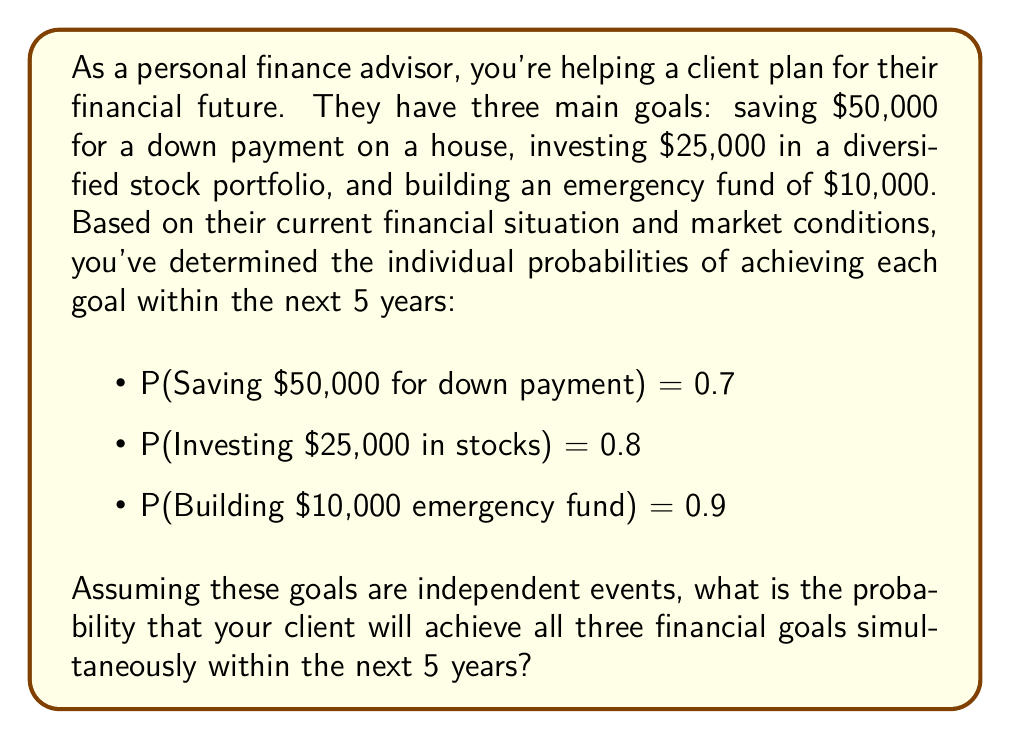Could you help me with this problem? To solve this problem, we need to use the multiplication rule for independent events. Since the question states that these goals are independent, we can multiply their individual probabilities to find the joint probability of all three events occurring simultaneously.

Let's define our events:
A = Saving $50,000 for down payment
B = Investing $25,000 in stocks
C = Building $10,000 emergency fund

We're given:
P(A) = 0.7
P(B) = 0.8
P(C) = 0.9

The joint probability of all three events occurring is:

$$P(A \cap B \cap C) = P(A) \times P(B) \times P(C)$$

Substituting the values:

$$P(A \cap B \cap C) = 0.7 \times 0.8 \times 0.9$$

Calculating:

$$P(A \cap B \cap C) = 0.504$$

Therefore, the probability of achieving all three financial goals simultaneously within the next 5 years is 0.504 or 50.4%.
Answer: 0.504 